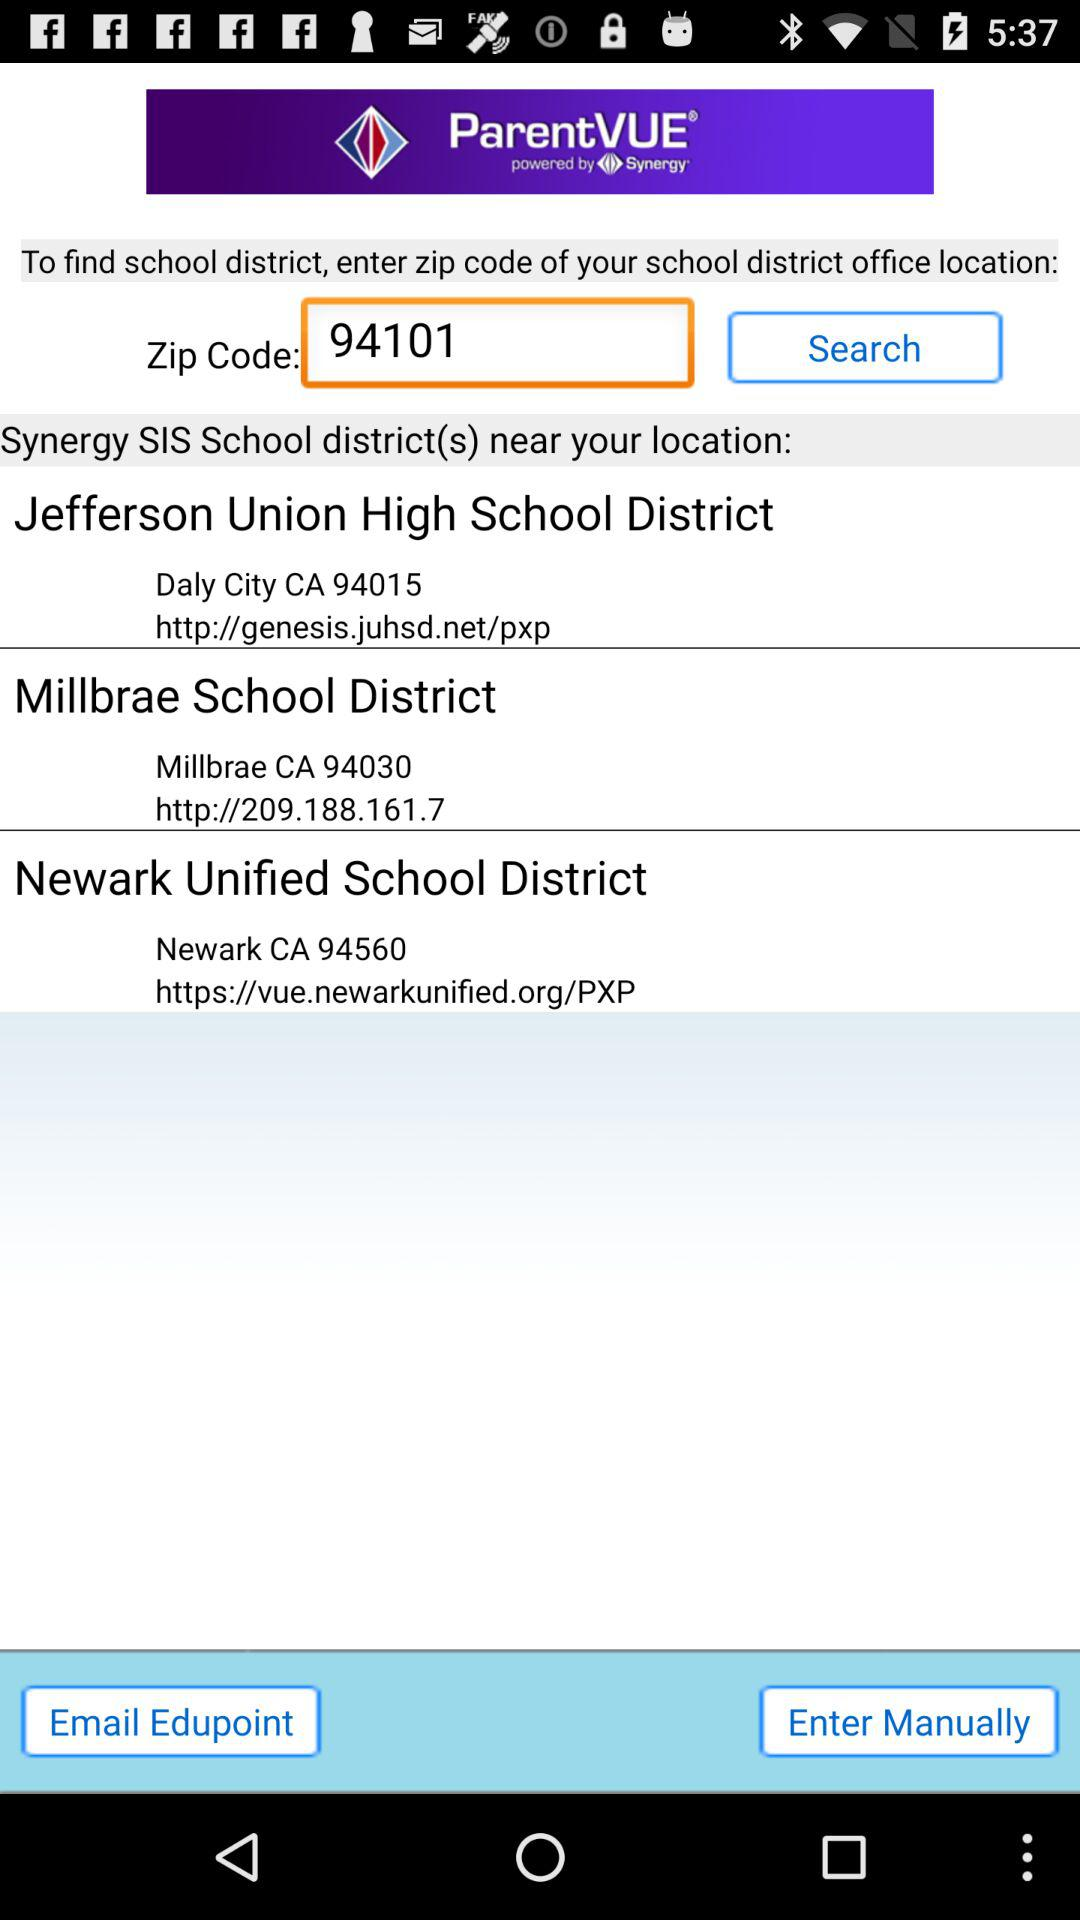What is the office location of "Millbrae School District"? The location is "Millbrae CA 94030". 